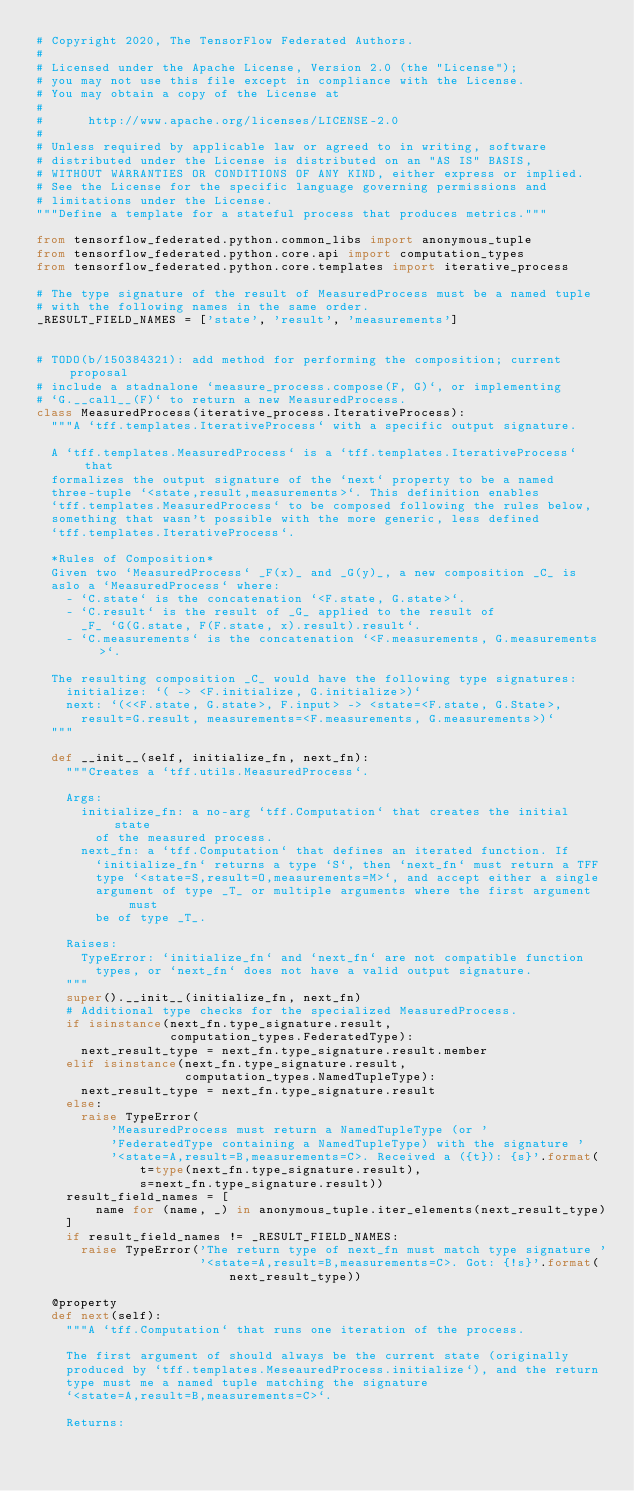<code> <loc_0><loc_0><loc_500><loc_500><_Python_># Copyright 2020, The TensorFlow Federated Authors.
#
# Licensed under the Apache License, Version 2.0 (the "License");
# you may not use this file except in compliance with the License.
# You may obtain a copy of the License at
#
#      http://www.apache.org/licenses/LICENSE-2.0
#
# Unless required by applicable law or agreed to in writing, software
# distributed under the License is distributed on an "AS IS" BASIS,
# WITHOUT WARRANTIES OR CONDITIONS OF ANY KIND, either express or implied.
# See the License for the specific language governing permissions and
# limitations under the License.
"""Define a template for a stateful process that produces metrics."""

from tensorflow_federated.python.common_libs import anonymous_tuple
from tensorflow_federated.python.core.api import computation_types
from tensorflow_federated.python.core.templates import iterative_process

# The type signature of the result of MeasuredProcess must be a named tuple
# with the following names in the same order.
_RESULT_FIELD_NAMES = ['state', 'result', 'measurements']


# TODO(b/150384321): add method for performing the composition; current proposal
# include a stadnalone `measure_process.compose(F, G)`, or implementing
# `G.__call__(F)` to return a new MeasuredProcess.
class MeasuredProcess(iterative_process.IterativeProcess):
  """A `tff.templates.IterativeProcess` with a specific output signature.

  A `tff.templates.MeasuredProcess` is a `tff.templates.IterativeProcess` that
  formalizes the output signature of the `next` property to be a named
  three-tuple `<state,result,measurements>`. This definition enables
  `tff.templates.MeasuredProcess` to be composed following the rules below,
  something that wasn't possible with the more generic, less defined
  `tff.templates.IterativeProcess`.

  *Rules of Composition*
  Given two `MeasuredProcess` _F(x)_ and _G(y)_, a new composition _C_ is
  aslo a `MeasuredProcess` where:
    - `C.state` is the concatenation `<F.state, G.state>`.
    - `C.result` is the result of _G_ applied to the result of
      _F_ `G(G.state, F(F.state, x).result).result`.
    - `C.measurements` is the concatenation `<F.measurements, G.measurements>`.

  The resulting composition _C_ would have the following type signatures:
    initialize: `( -> <F.initialize, G.initialize>)`
    next: `(<<F.state, G.state>, F.input> -> <state=<F.state, G.State>,
      result=G.result, measurements=<F.measurements, G.measurements>)`
  """

  def __init__(self, initialize_fn, next_fn):
    """Creates a `tff.utils.MeasuredProcess`.

    Args:
      initialize_fn: a no-arg `tff.Computation` that creates the initial state
        of the measured process.
      next_fn: a `tff.Computation` that defines an iterated function. If
        `initialize_fn` returns a type `S`, then `next_fn` must return a TFF
        type `<state=S,result=O,measurements=M>`, and accept either a single
        argument of type _T_ or multiple arguments where the first argument must
        be of type _T_.

    Raises:
      TypeError: `initialize_fn` and `next_fn` are not compatible function
        types, or `next_fn` does not have a valid output signature.
    """
    super().__init__(initialize_fn, next_fn)
    # Additional type checks for the specialized MeasuredProcess.
    if isinstance(next_fn.type_signature.result,
                  computation_types.FederatedType):
      next_result_type = next_fn.type_signature.result.member
    elif isinstance(next_fn.type_signature.result,
                    computation_types.NamedTupleType):
      next_result_type = next_fn.type_signature.result
    else:
      raise TypeError(
          'MeasuredProcess must return a NamedTupleType (or '
          'FederatedType containing a NamedTupleType) with the signature '
          '<state=A,result=B,measurements=C>. Received a ({t}): {s}'.format(
              t=type(next_fn.type_signature.result),
              s=next_fn.type_signature.result))
    result_field_names = [
        name for (name, _) in anonymous_tuple.iter_elements(next_result_type)
    ]
    if result_field_names != _RESULT_FIELD_NAMES:
      raise TypeError('The return type of next_fn must match type signature '
                      '<state=A,result=B,measurements=C>. Got: {!s}'.format(
                          next_result_type))

  @property
  def next(self):
    """A `tff.Computation` that runs one iteration of the process.

    The first argument of should always be the current state (originally
    produced by `tff.templates.MeseauredProcess.initialize`), and the return
    type must me a named tuple matching the signature
    `<state=A,result=B,measurements=C>`.

    Returns:</code> 